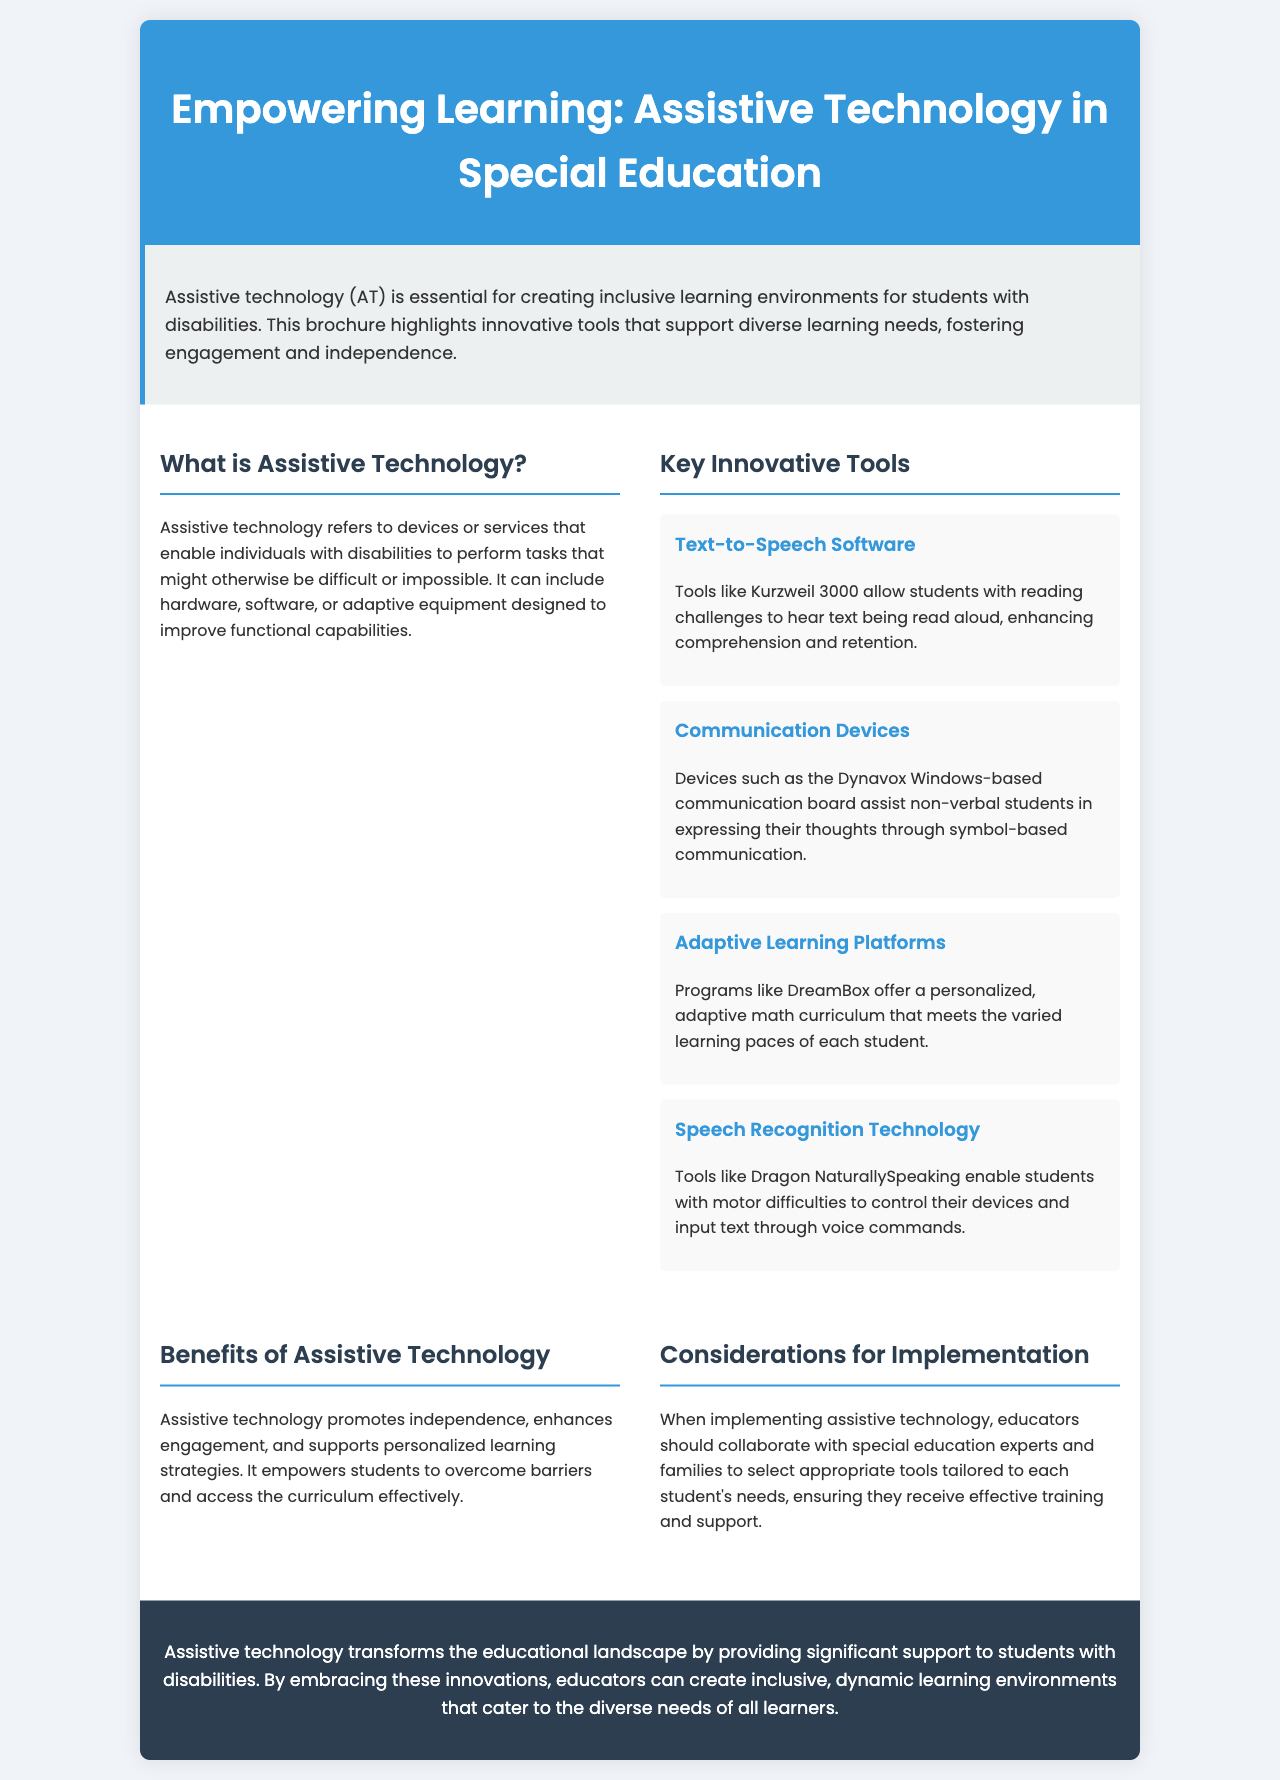what is the title of the brochure? The title is prominently displayed at the top of the document.
Answer: Empowering Learning: Assistive Technology in Special Education what does assistive technology refer to? The document defines assistive technology in a specific section.
Answer: Devices or services that enable individuals with disabilities to perform tasks which tool assists non-verbal students? The document mentions a specific communication device for non-verbal students.
Answer: Dynavox Windows-based communication board what is the benefit of assistive technology mentioned in the document? The document lists benefits in a specific section about assistive technology.
Answer: Promotes independence name one adaptive learning platform mentioned. The document provides examples of innovative tools in the content section.
Answer: DreamBox how many innovative tools are highlighted? The document lists several tools under the "Key Innovative Tools" section.
Answer: Four who should educators collaborate with for implementation? The document specifies key parties for collaboration when implementing technology.
Answer: Special education experts and families what color is used for the header background? The document describes the color scheme used in the brochure design.
Answer: Blue what is the conclusion about assistive technology's impact? The last section summarizes the overall message and impact of the technology.
Answer: Transforms the educational landscape 